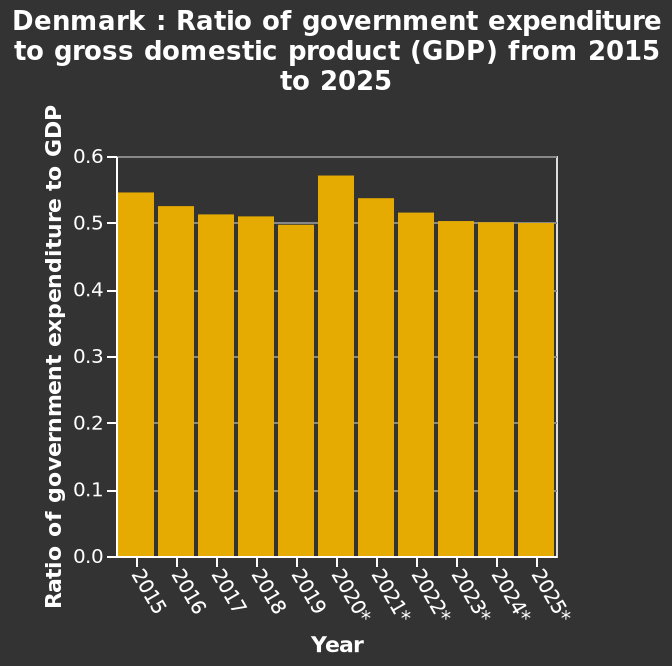<image>
When was government spending at its highest?  Government spending was at its highest in 2020. Has government spending increased or decreased since 2020?  Government spending has decreased since 2020, with a steady decline. Offer a thorough analysis of the image. The bar chart shows that goverment spending was at its highest in 2020. There has been a steady decline since 2021 and the hope is to remain on a level pace of spending for the coming years. Was government spending at its highest in 2020? No.The bar chart shows that goverment spending was at its highest in 2020. There has been a steady decline since 2021 and the hope is to remain on a level pace of spending for the coming years. 